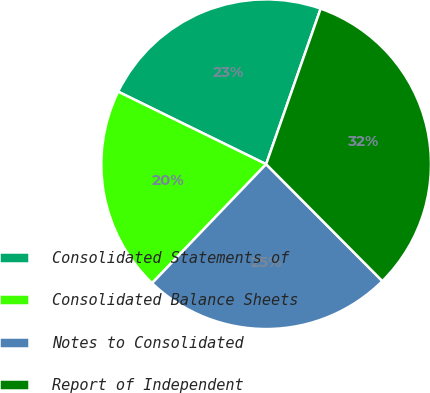Convert chart to OTSL. <chart><loc_0><loc_0><loc_500><loc_500><pie_chart><fcel>Consolidated Statements of<fcel>Consolidated Balance Sheets<fcel>Notes to Consolidated<fcel>Report of Independent<nl><fcel>23.11%<fcel>20.09%<fcel>24.62%<fcel>32.18%<nl></chart> 